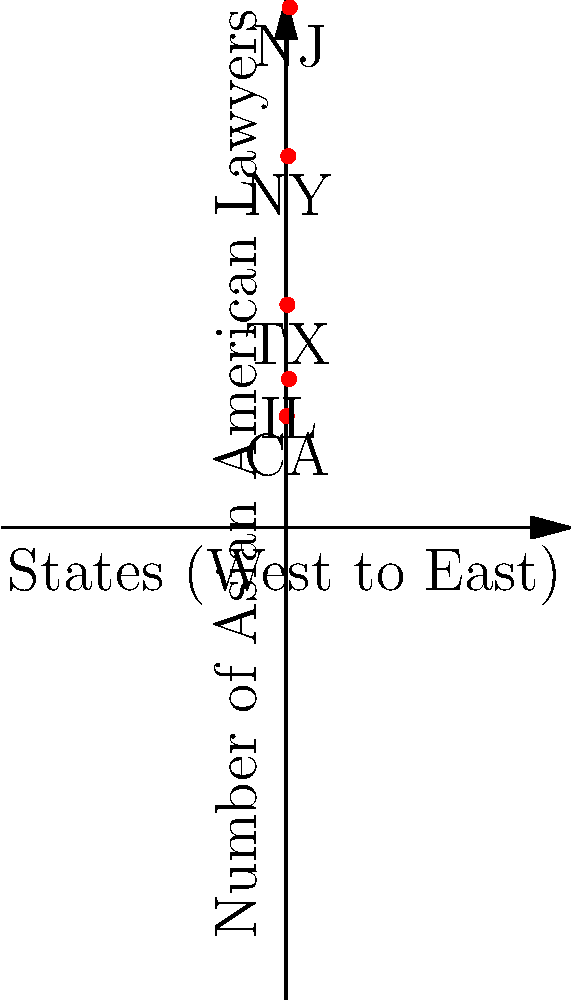The graph above represents the distribution of Asian American lawyers across five states from West to East. If the x-axis represents the states' positions from West to East and the y-axis represents the number of Asian American lawyers, what is the slope of the line connecting the data points for California (CA) and New Jersey (NJ)? To find the slope of the line connecting California (CA) and New Jersey (NJ), we'll use the slope formula:

$$ m = \frac{y_2 - y_1}{x_2 - x_1} $$

Where $(x_1, y_1)$ is the point for CA and $(x_2, y_2)$ is the point for NJ.

Step 1: Identify the coordinates
CA: $(1, 150)$
NJ: $(5, 700)$

Step 2: Apply the slope formula
$$ m = \frac{700 - 150}{5 - 1} = \frac{550}{4} $$

Step 3: Simplify the fraction
$$ m = 137.5 $$

Therefore, the slope of the line connecting CA and NJ is 137.5, representing an increase of 137.5 Asian American lawyers per unit change in the West to East direction.
Answer: 137.5 